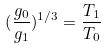Convert formula to latex. <formula><loc_0><loc_0><loc_500><loc_500>( \frac { g _ { 0 } } { g _ { 1 } } ) ^ { 1 / 3 } = \frac { T _ { 1 } } { T _ { 0 } }</formula> 